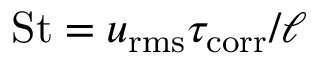Convert formula to latex. <formula><loc_0><loc_0><loc_500><loc_500>S t = u _ { r m s } \tau _ { c o r r } / \ell</formula> 